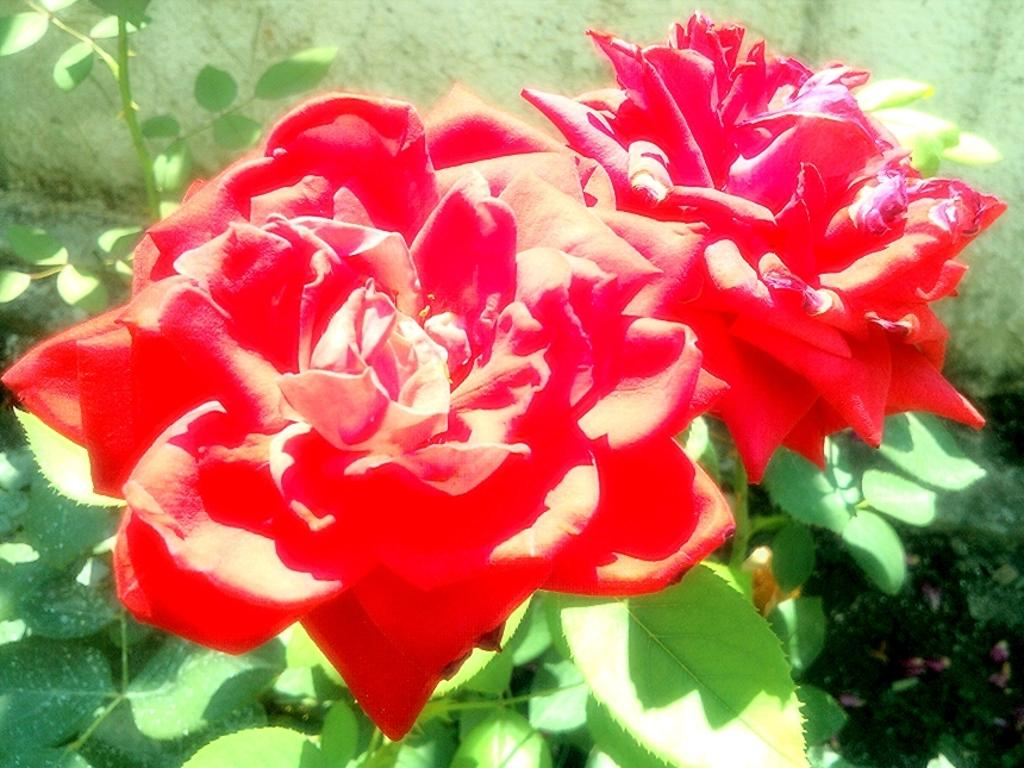How many flowers can be seen in the image? There are two red flowers in the image. What color are the flowers? The flowers are red. What is the flowers' connection to the plants in the image? The flowers are attached to green plants. What can be seen in the background of the image? There is a wall and the ground visible in the background of the image. What type of lipstick is being advertised on the wall in the image? There is no lipstick or advertisement present in the image; it features two red flowers attached to green plants with a wall and the ground visible in the background. 